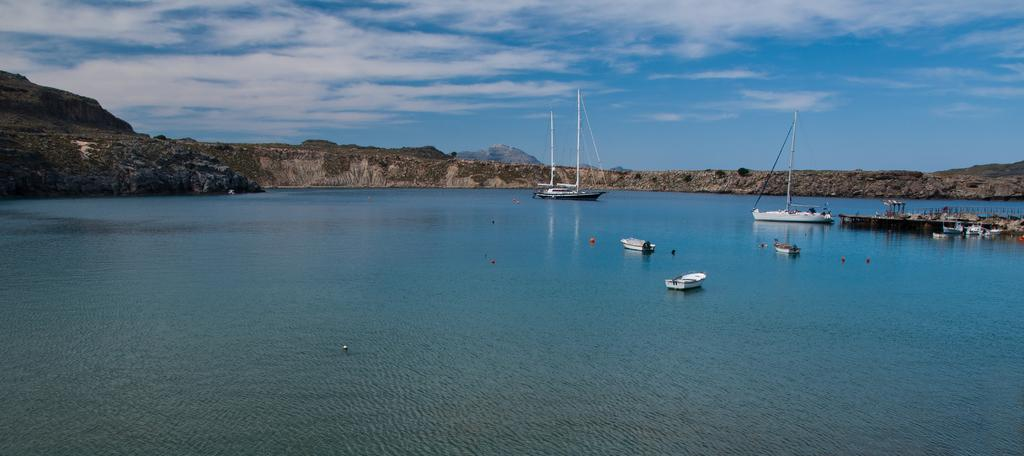What types of watercraft are present in the image? There are ships and boats in the image. What can be seen above the water in the image? There are objects above the water, such as the ships, boats, and a bridge. What is visible in the background of the image? In the background of the image, there is grass, a hill, and sky visible. What is the condition of the sky in the image? The sky in the image has clouds visible. What type of underwear is hanging on the bridge in the image? There is no underwear present in the image; it only features ships, boats, a bridge, grass, a hill, and sky. What kind of pancake is being served on the boats in the image? There is no pancake present in the image; it only features ships, boats, a bridge, grass, a hill, and sky. 